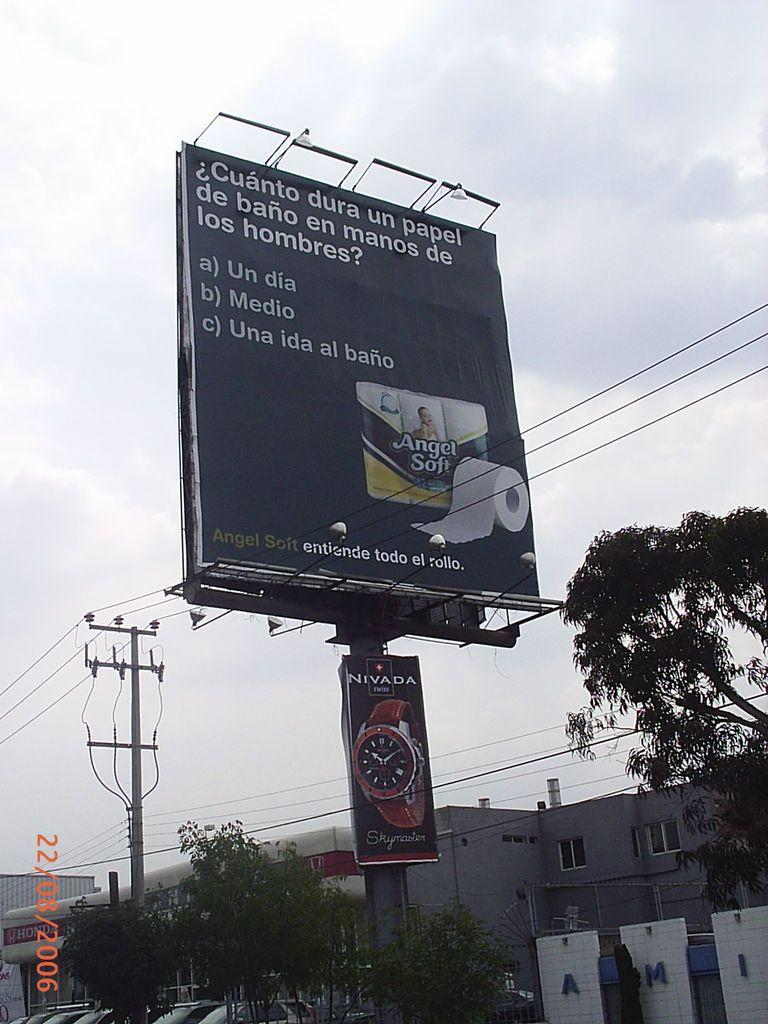<image>
Offer a succinct explanation of the picture presented. A billboard advertising Angel Soft bathroom tissues, rises over some buildings. 